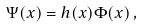<formula> <loc_0><loc_0><loc_500><loc_500>\Psi ( x ) = h ( x ) \Phi ( x ) \, ,</formula> 